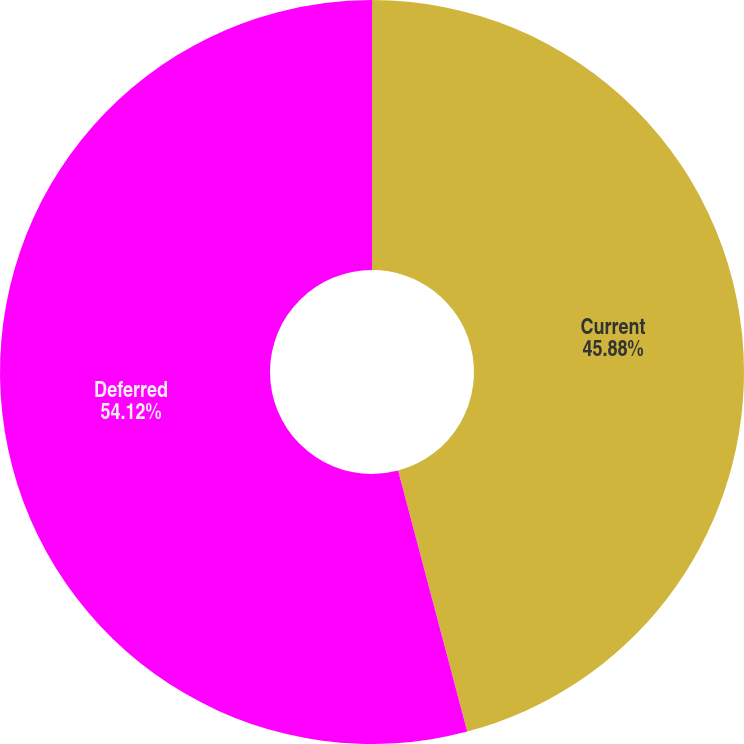Convert chart. <chart><loc_0><loc_0><loc_500><loc_500><pie_chart><fcel>Current<fcel>Deferred<nl><fcel>45.88%<fcel>54.12%<nl></chart> 